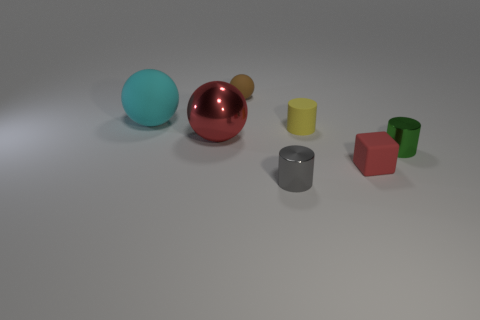Subtract all big red spheres. How many spheres are left? 2 Add 1 large gray rubber cylinders. How many objects exist? 8 Subtract all balls. How many objects are left? 4 Add 7 small brown balls. How many small brown balls exist? 8 Subtract 1 red blocks. How many objects are left? 6 Subtract all cyan cylinders. Subtract all brown blocks. How many cylinders are left? 3 Subtract all tiny red metal blocks. Subtract all green cylinders. How many objects are left? 6 Add 7 small matte spheres. How many small matte spheres are left? 8 